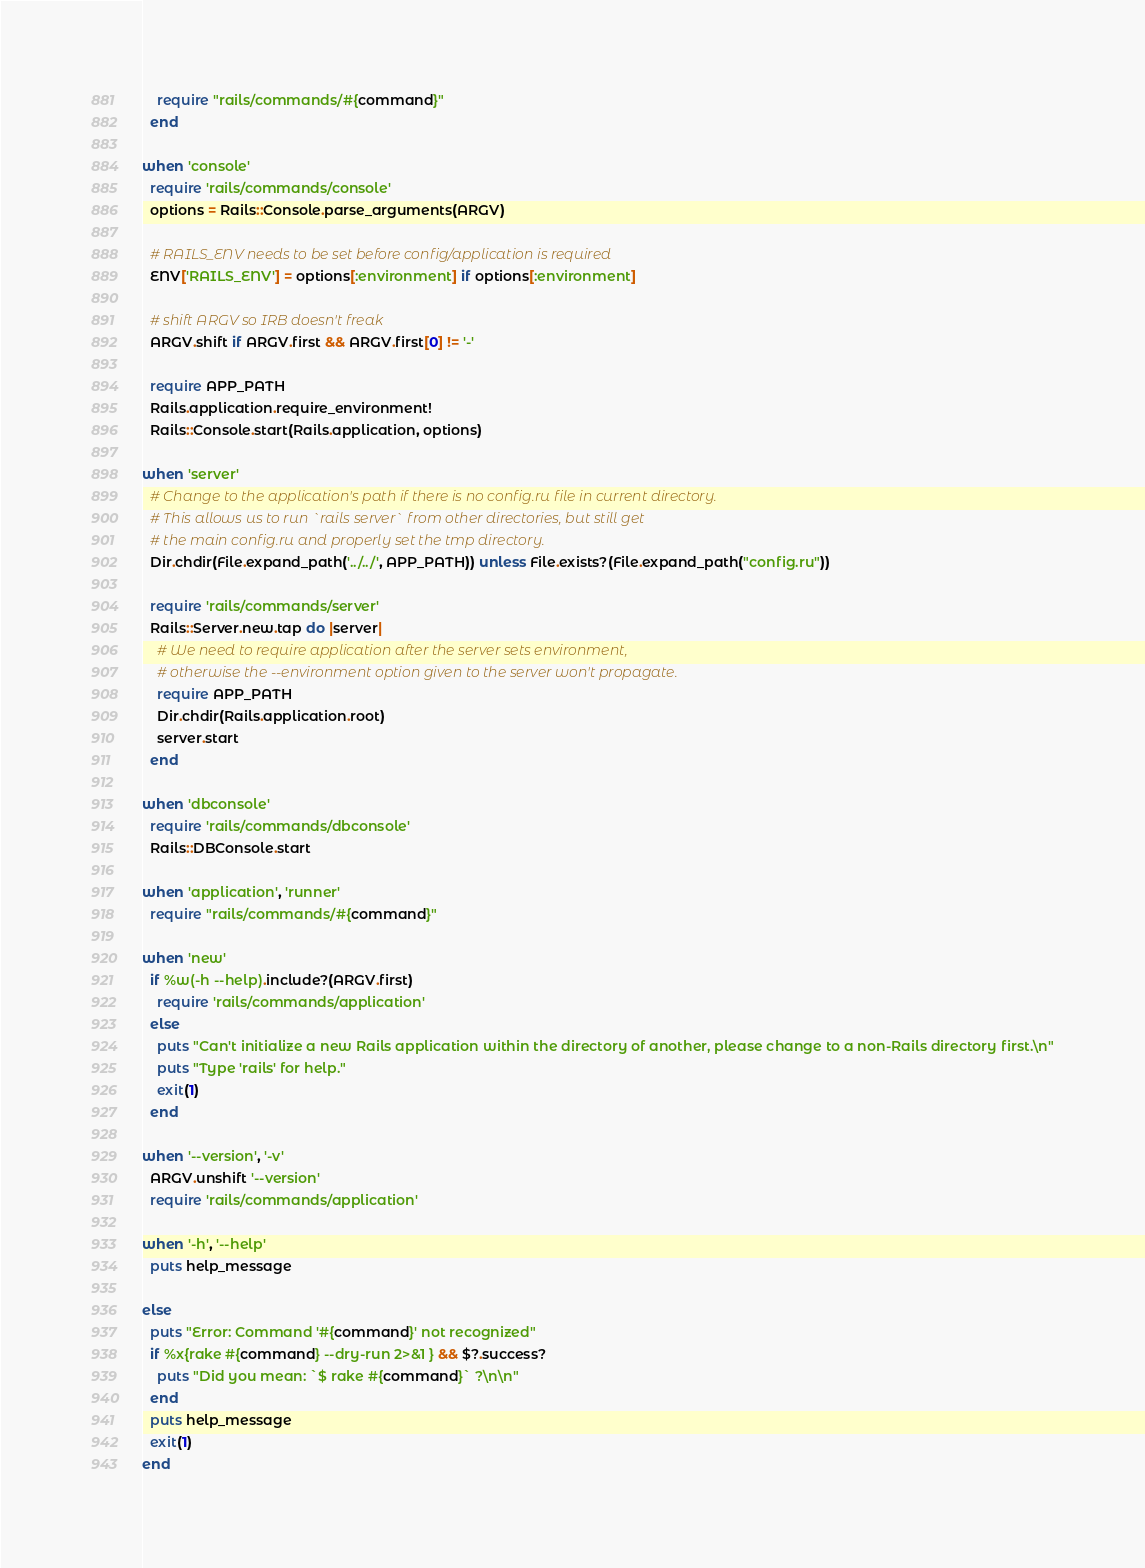Convert code to text. <code><loc_0><loc_0><loc_500><loc_500><_Ruby_>    require "rails/commands/#{command}"
  end

when 'console'
  require 'rails/commands/console'
  options = Rails::Console.parse_arguments(ARGV)

  # RAILS_ENV needs to be set before config/application is required
  ENV['RAILS_ENV'] = options[:environment] if options[:environment]

  # shift ARGV so IRB doesn't freak
  ARGV.shift if ARGV.first && ARGV.first[0] != '-'

  require APP_PATH
  Rails.application.require_environment!
  Rails::Console.start(Rails.application, options)

when 'server'
  # Change to the application's path if there is no config.ru file in current directory.
  # This allows us to run `rails server` from other directories, but still get
  # the main config.ru and properly set the tmp directory.
  Dir.chdir(File.expand_path('../../', APP_PATH)) unless File.exists?(File.expand_path("config.ru"))

  require 'rails/commands/server'
  Rails::Server.new.tap do |server|
    # We need to require application after the server sets environment,
    # otherwise the --environment option given to the server won't propagate.
    require APP_PATH
    Dir.chdir(Rails.application.root)
    server.start
  end

when 'dbconsole'
  require 'rails/commands/dbconsole'
  Rails::DBConsole.start

when 'application', 'runner'
  require "rails/commands/#{command}"

when 'new'
  if %w(-h --help).include?(ARGV.first)
    require 'rails/commands/application'
  else
    puts "Can't initialize a new Rails application within the directory of another, please change to a non-Rails directory first.\n"
    puts "Type 'rails' for help."
    exit(1)
  end

when '--version', '-v'
  ARGV.unshift '--version'
  require 'rails/commands/application'

when '-h', '--help'
  puts help_message

else
  puts "Error: Command '#{command}' not recognized"
  if %x{rake #{command} --dry-run 2>&1 } && $?.success?
    puts "Did you mean: `$ rake #{command}` ?\n\n"
  end
  puts help_message
  exit(1)
end
</code> 